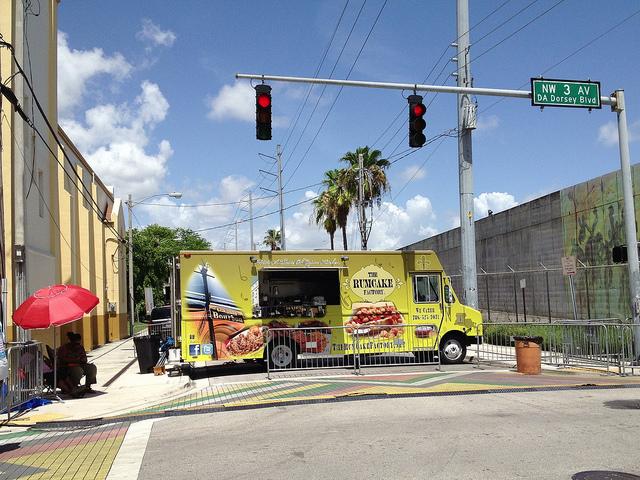What color light is on the traffic light?
Keep it brief. Red. Is this a food truck?
Short answer required. Yes. What is the color of the traffic light?
Keep it brief. Red. What color is the umbrella?
Quick response, please. Red. What kind of food do they serve at the restaurant?
Give a very brief answer. Rum cake. Is the stop light red?
Answer briefly. Yes. What is the name of the restaurant?
Short answer required. Rum cake. What color is the car in the parking lot?
Keep it brief. Yellow. 